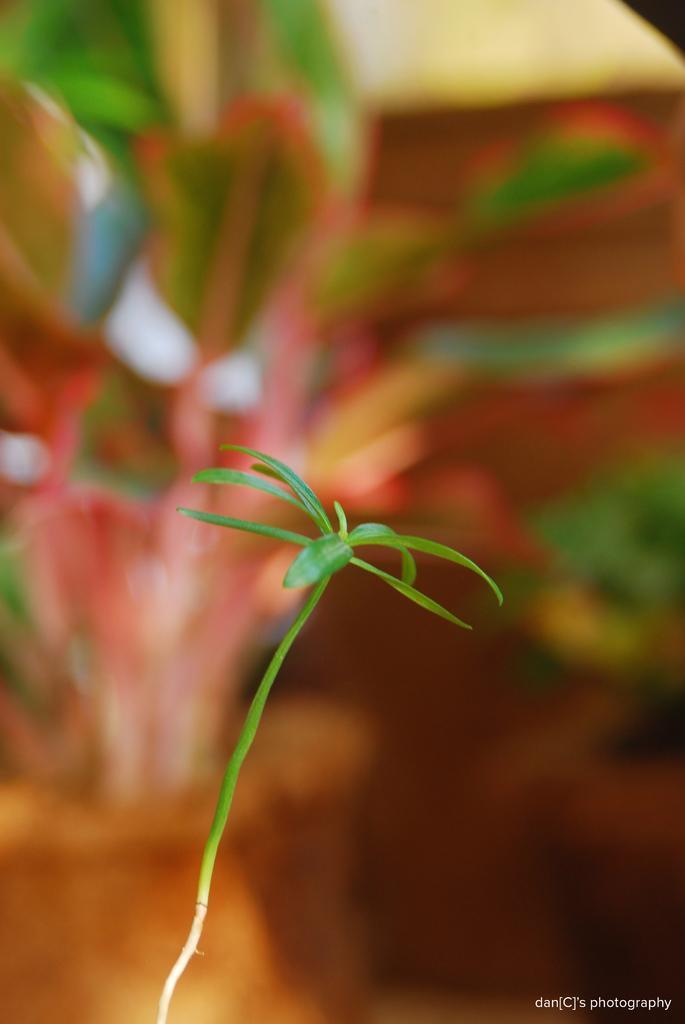How would you summarize this image in a sentence or two? In this image we can see a plant. The background of the image is blur. On the image there is a watermark. 